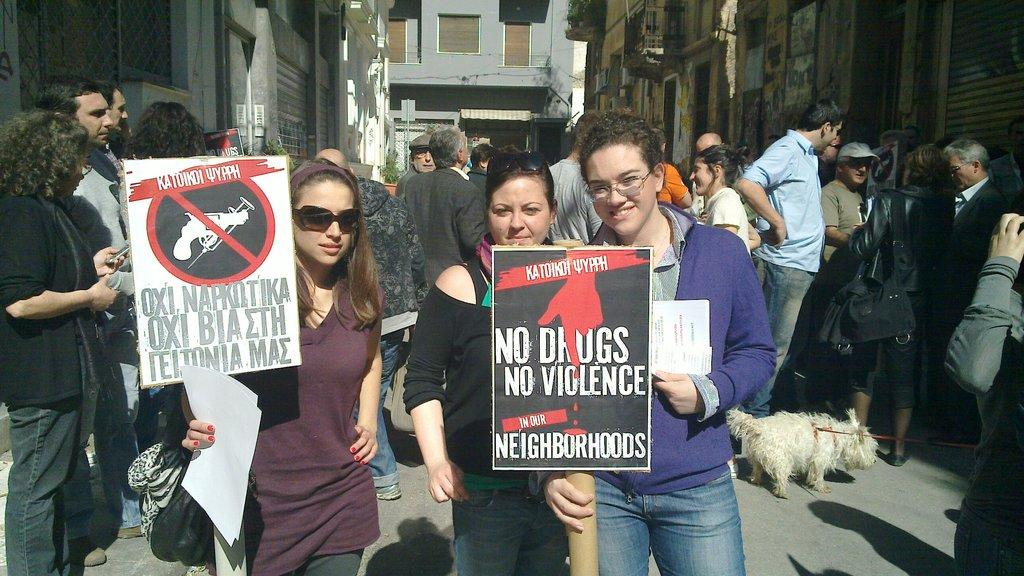What are the people in the image doing? The people in the image are standing and walking. Are there any objects or items being held by the people? Yes, some people are holding banners in their hands. What can be seen in the background of the image? There are buildings in the background of the image. What type of jam is being spread on the cows in the image? There are no cows or jam present in the image. How is the sister involved in the scene depicted in the image? There is no mention of a sister in the image, so we cannot determine her involvement. 